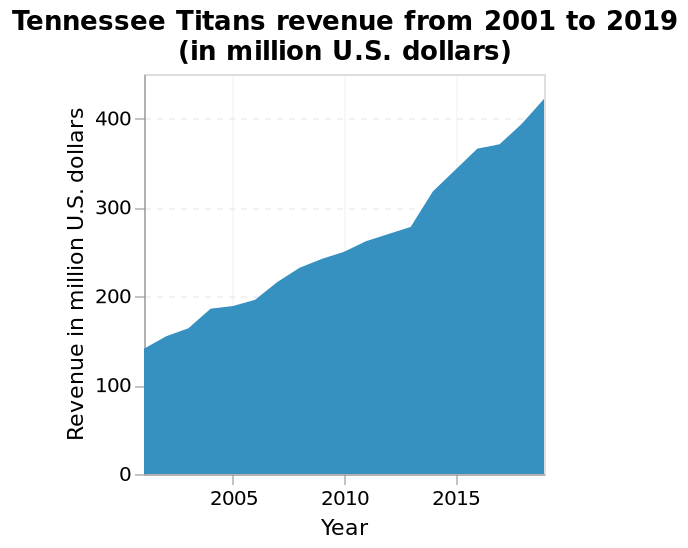<image>
What is the highest recorded revenue for the Tennessee Titans?  The highest recorded revenue for the Tennessee Titans is not specified in the given information. How would you describe the trend of the Titans' revenue over time?  The trend of the Titans' revenue over time is steadily increasing. When did the Titans' revenue peak?  The Titans' revenue peaked around 2020. What is the range of the y-axis in the Tennessee Titans revenue graph?  The range of the y-axis is from 0 to 400 million U.S. dollars. 